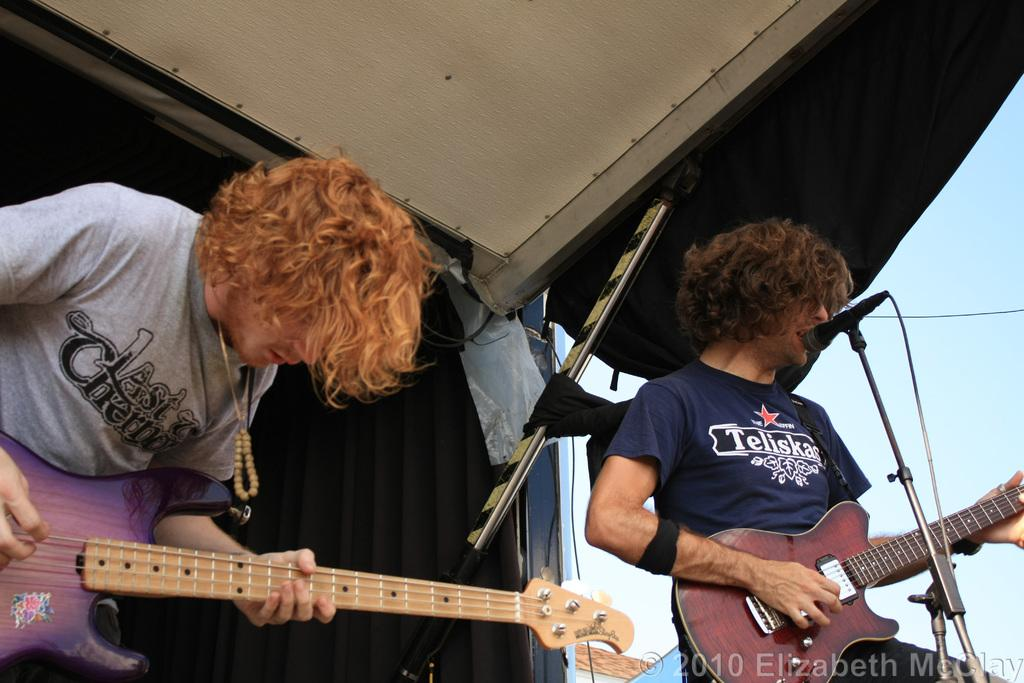How many people are in the image? There are two men in the image. What are the men doing in the image? The men are standing and holding guitars in their hands. Can you describe the position of one of the men? One man is in front of a microphone. What can be seen in the background of the image? There is a black cloth in the background of the image. What type of bag can be seen near the harbor in the image? There is no bag or harbor present in the image. 